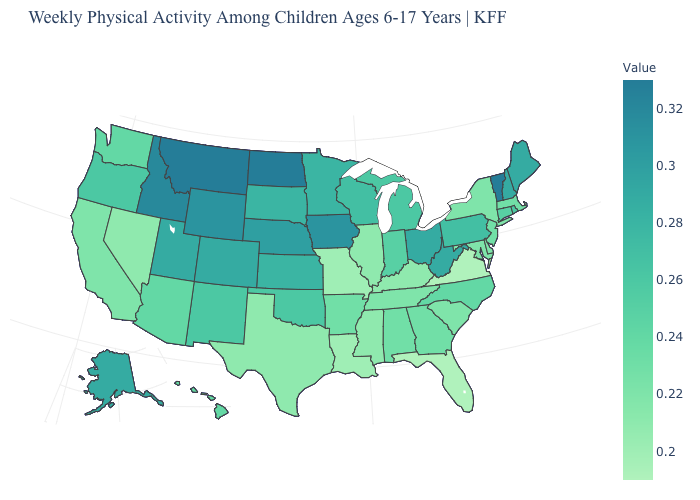Is the legend a continuous bar?
Give a very brief answer. Yes. Does the map have missing data?
Answer briefly. No. Does Nevada have the lowest value in the West?
Keep it brief. Yes. Does Florida have the lowest value in the USA?
Be succinct. Yes. Among the states that border Oklahoma , which have the lowest value?
Keep it brief. Missouri. Does Florida have a lower value than New Hampshire?
Keep it brief. Yes. Which states have the highest value in the USA?
Give a very brief answer. Montana, North Dakota, Vermont. 